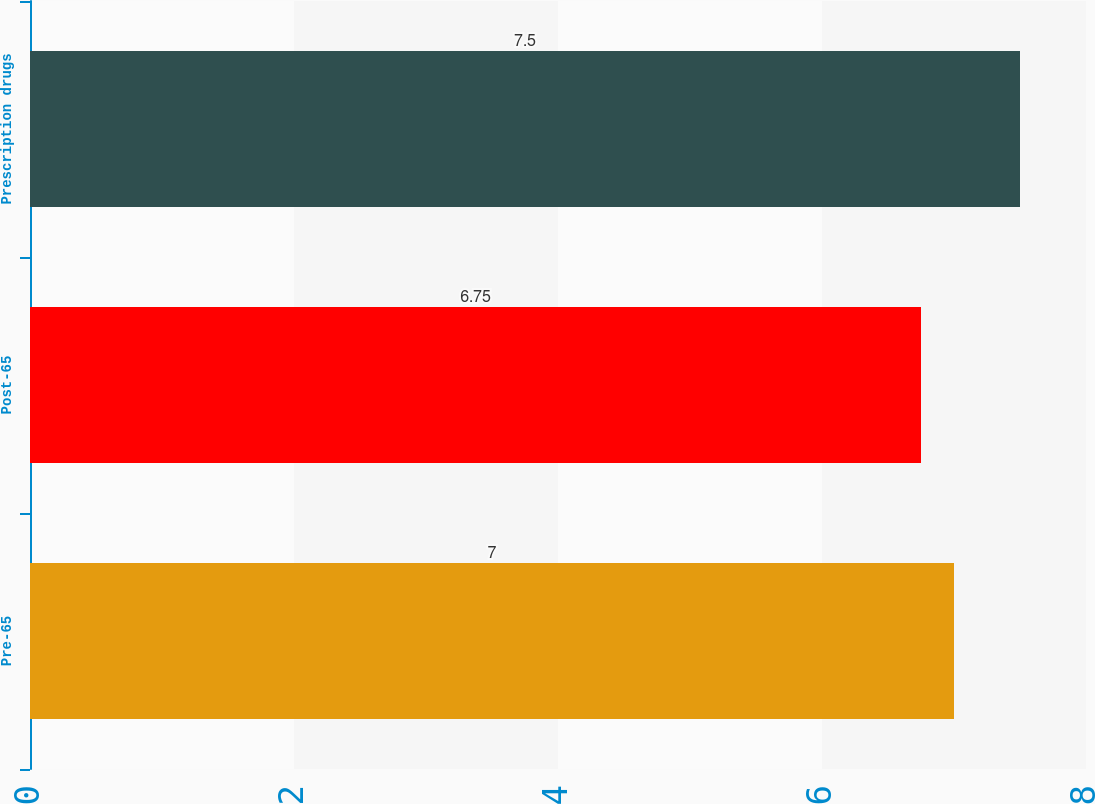Convert chart. <chart><loc_0><loc_0><loc_500><loc_500><bar_chart><fcel>Pre-65<fcel>Post-65<fcel>Prescription drugs<nl><fcel>7<fcel>6.75<fcel>7.5<nl></chart> 